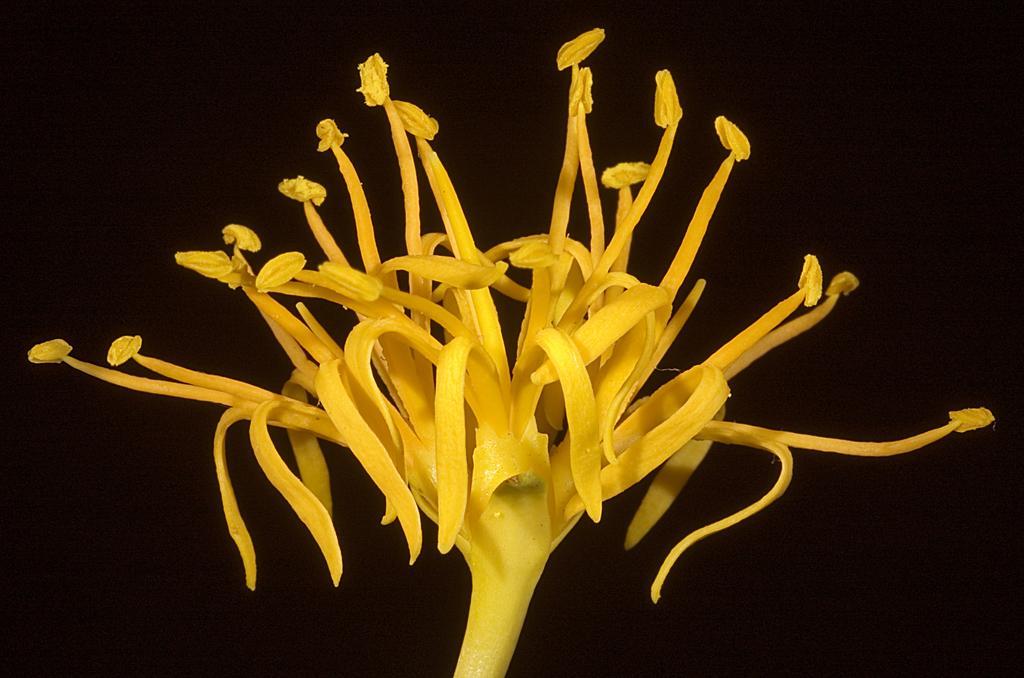Please provide a concise description of this image. In the image there is a yellow flower in the front and the background is black. 